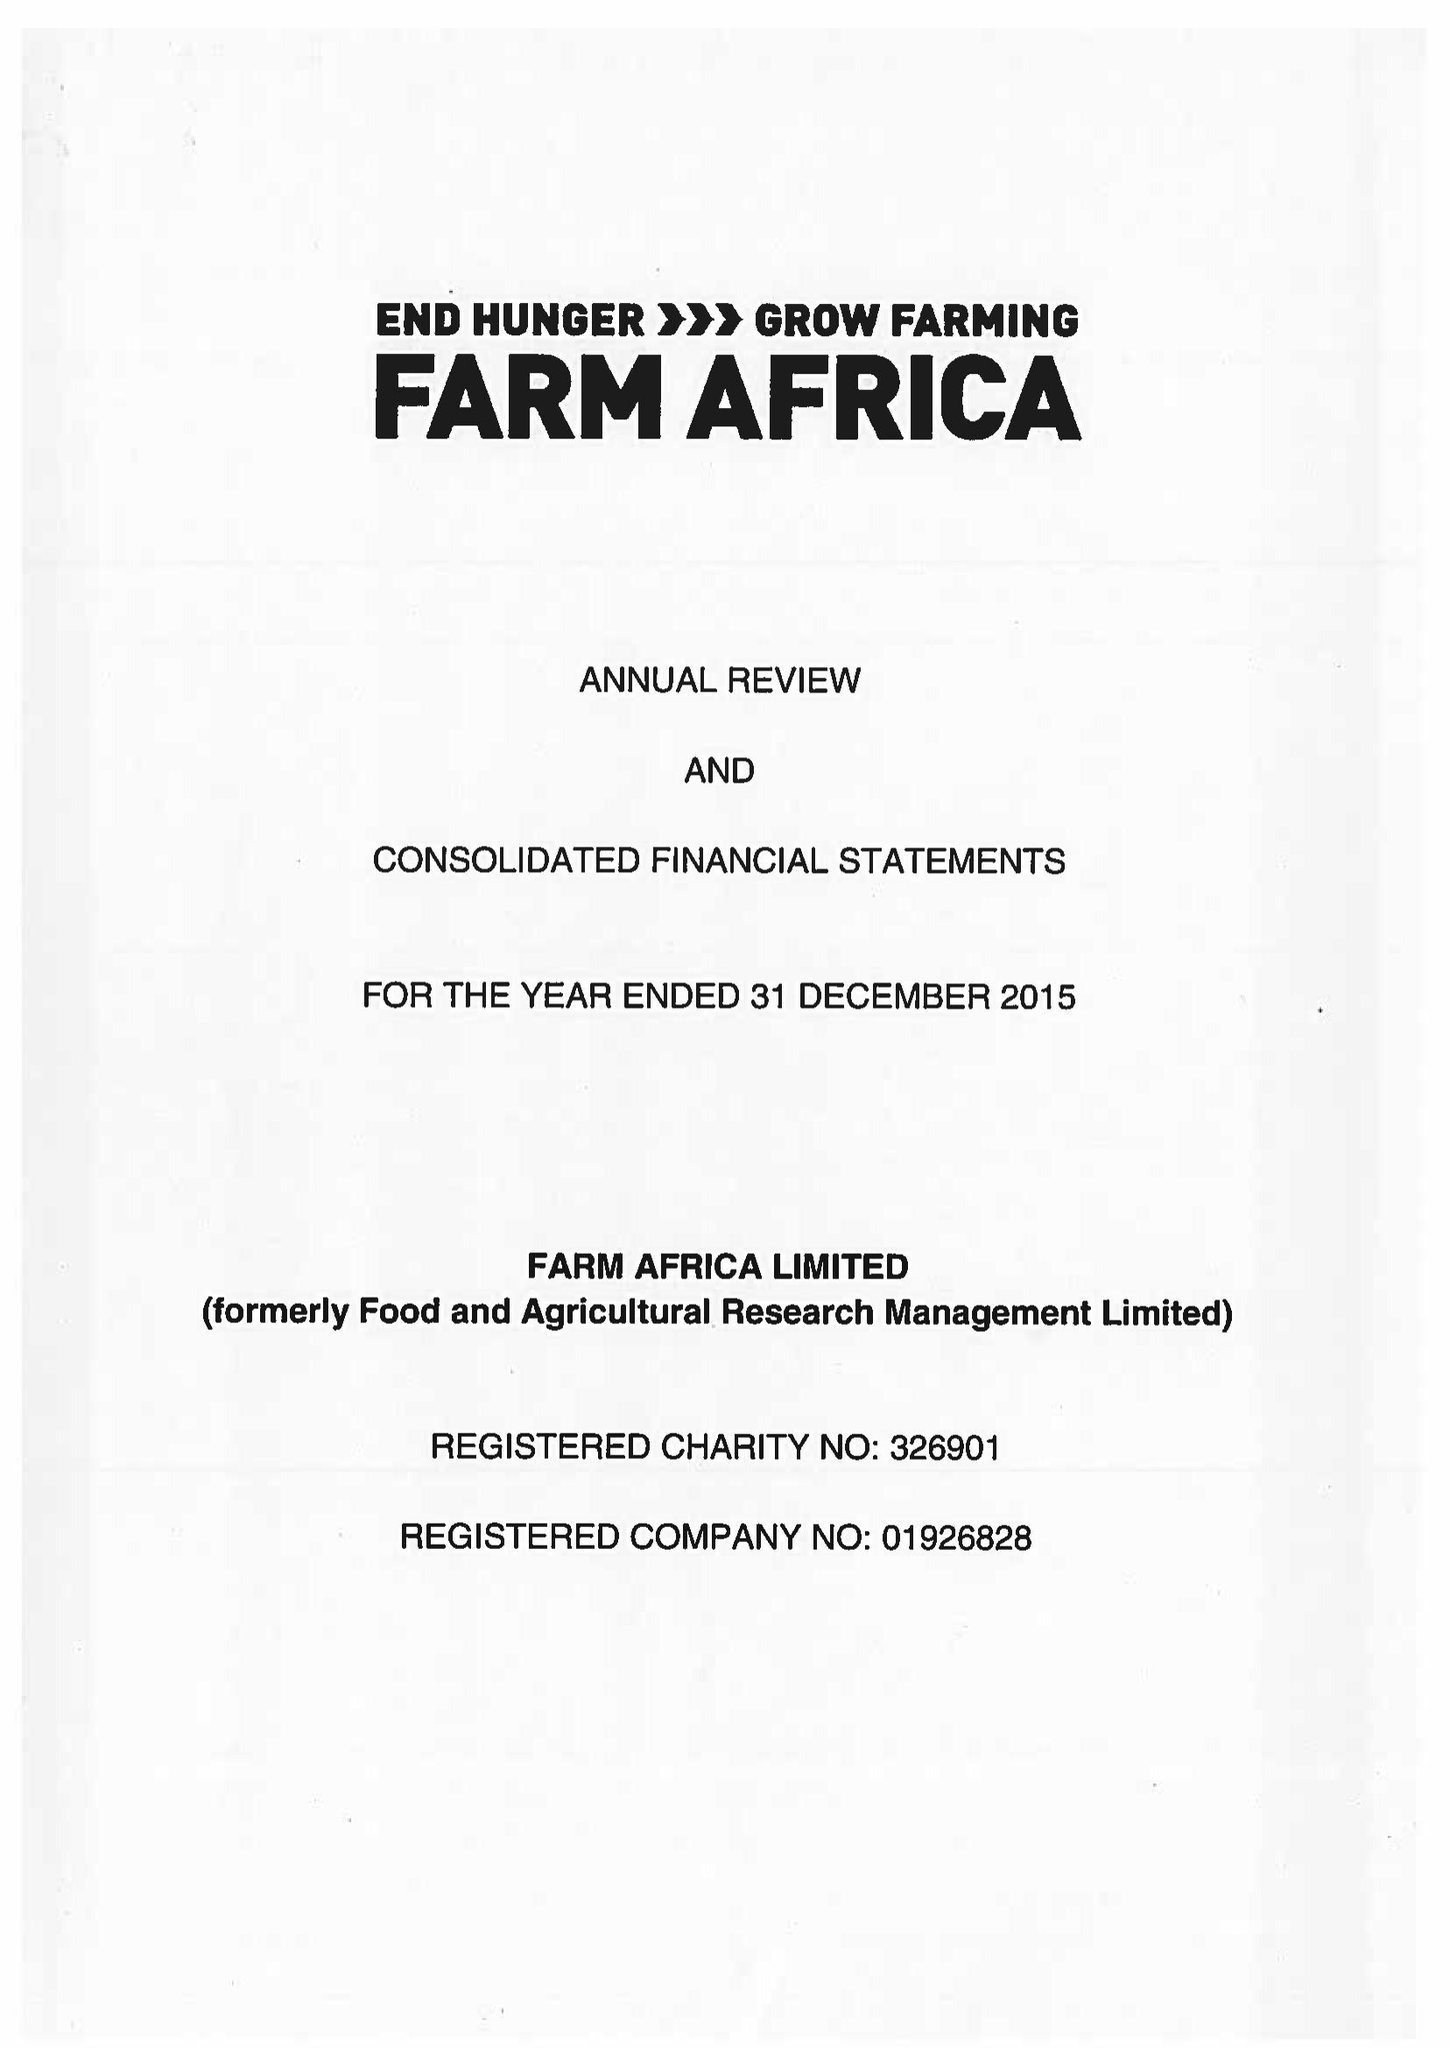What is the value for the report_date?
Answer the question using a single word or phrase. 2015-12-31 